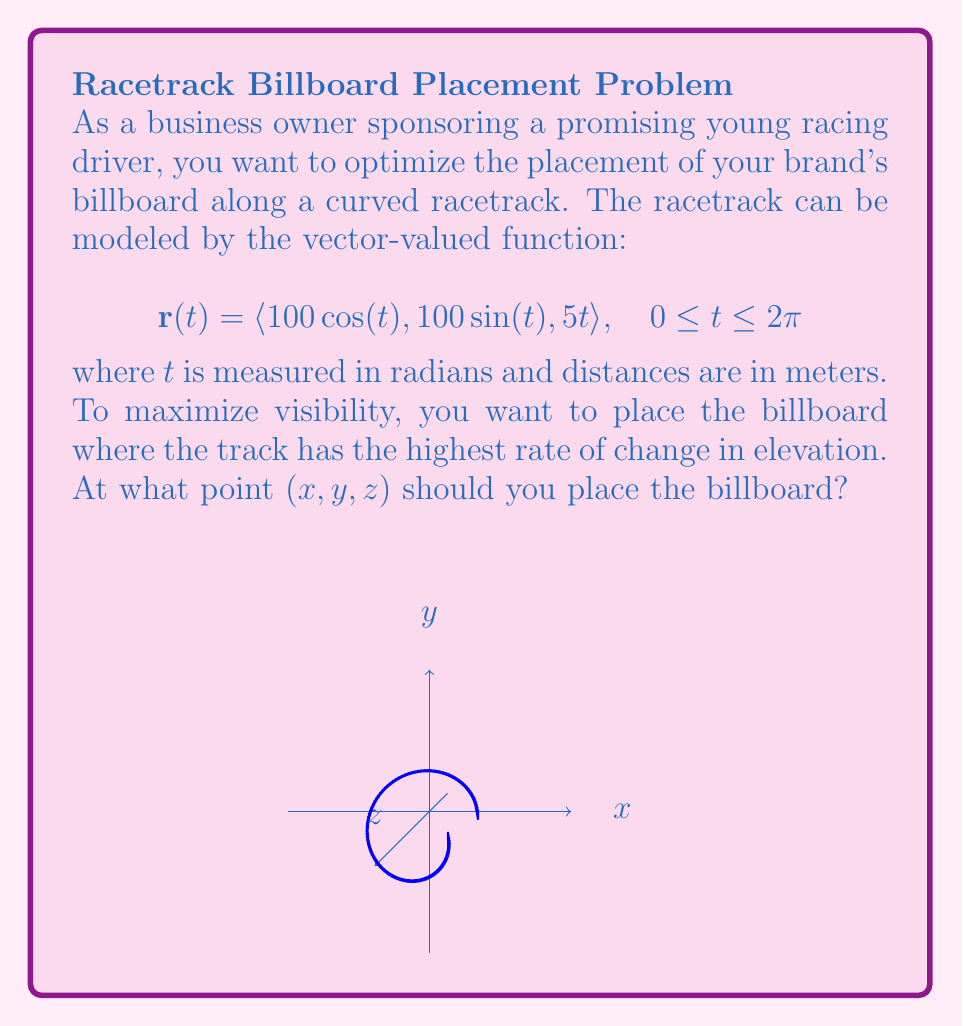Help me with this question. Let's approach this step-by-step:

1) The rate of change in elevation is given by the z-component of the velocity vector. We need to find the velocity vector $\mathbf{v}(t)$ by differentiating $\mathbf{r}(t)$:

   $$\mathbf{v}(t) = \mathbf{r}'(t) = \langle -100\sin(t), 100\cos(t), 5 \rangle$$

2) The z-component of the velocity vector is constant at 5 m/s. This means the rate of change in elevation is constant throughout the track.

3) Since the rate of change in elevation is constant, we can choose any point on the track for the billboard. Let's choose $t = 0$ for simplicity.

4) Substituting $t = 0$ into the original function $\mathbf{r}(t)$:

   $$\mathbf{r}(0) = \langle 100\cos(0), 100\sin(0), 5(0) \rangle = \langle 100, 0, 0 \rangle$$

5) Therefore, the optimal point for the billboard placement is (100, 0, 0).

Note: In this case, any point on the track would be equally optimal due to the constant rate of change in elevation. The choice of t = 0 was arbitrary and made for simplicity.
Answer: (100, 0, 0) 